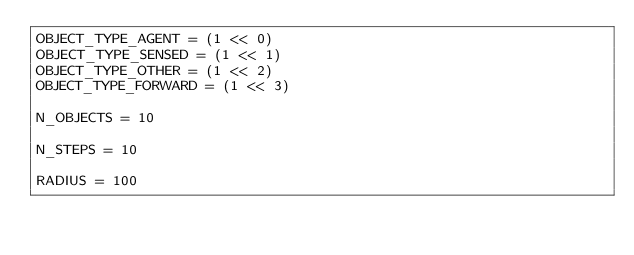Convert code to text. <code><loc_0><loc_0><loc_500><loc_500><_Python_>OBJECT_TYPE_AGENT = (1 << 0)
OBJECT_TYPE_SENSED = (1 << 1)
OBJECT_TYPE_OTHER = (1 << 2)
OBJECT_TYPE_FORWARD = (1 << 3)

N_OBJECTS = 10

N_STEPS = 10

RADIUS = 100
</code> 